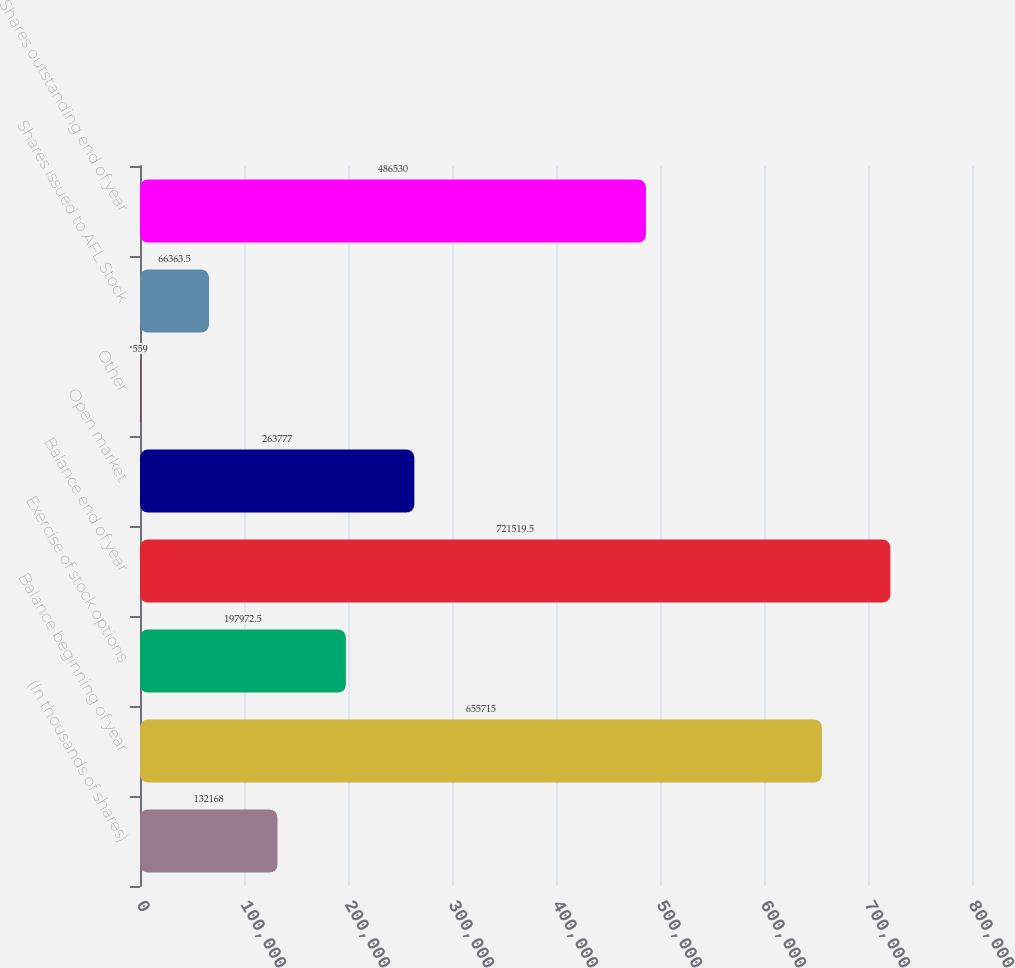<chart> <loc_0><loc_0><loc_500><loc_500><bar_chart><fcel>(In thousands of shares)<fcel>Balance beginning of year<fcel>Exercise of stock options<fcel>Balance end of year<fcel>Open market<fcel>Other<fcel>Shares issued to AFL Stock<fcel>Shares outstanding end of year<nl><fcel>132168<fcel>655715<fcel>197972<fcel>721520<fcel>263777<fcel>559<fcel>66363.5<fcel>486530<nl></chart> 